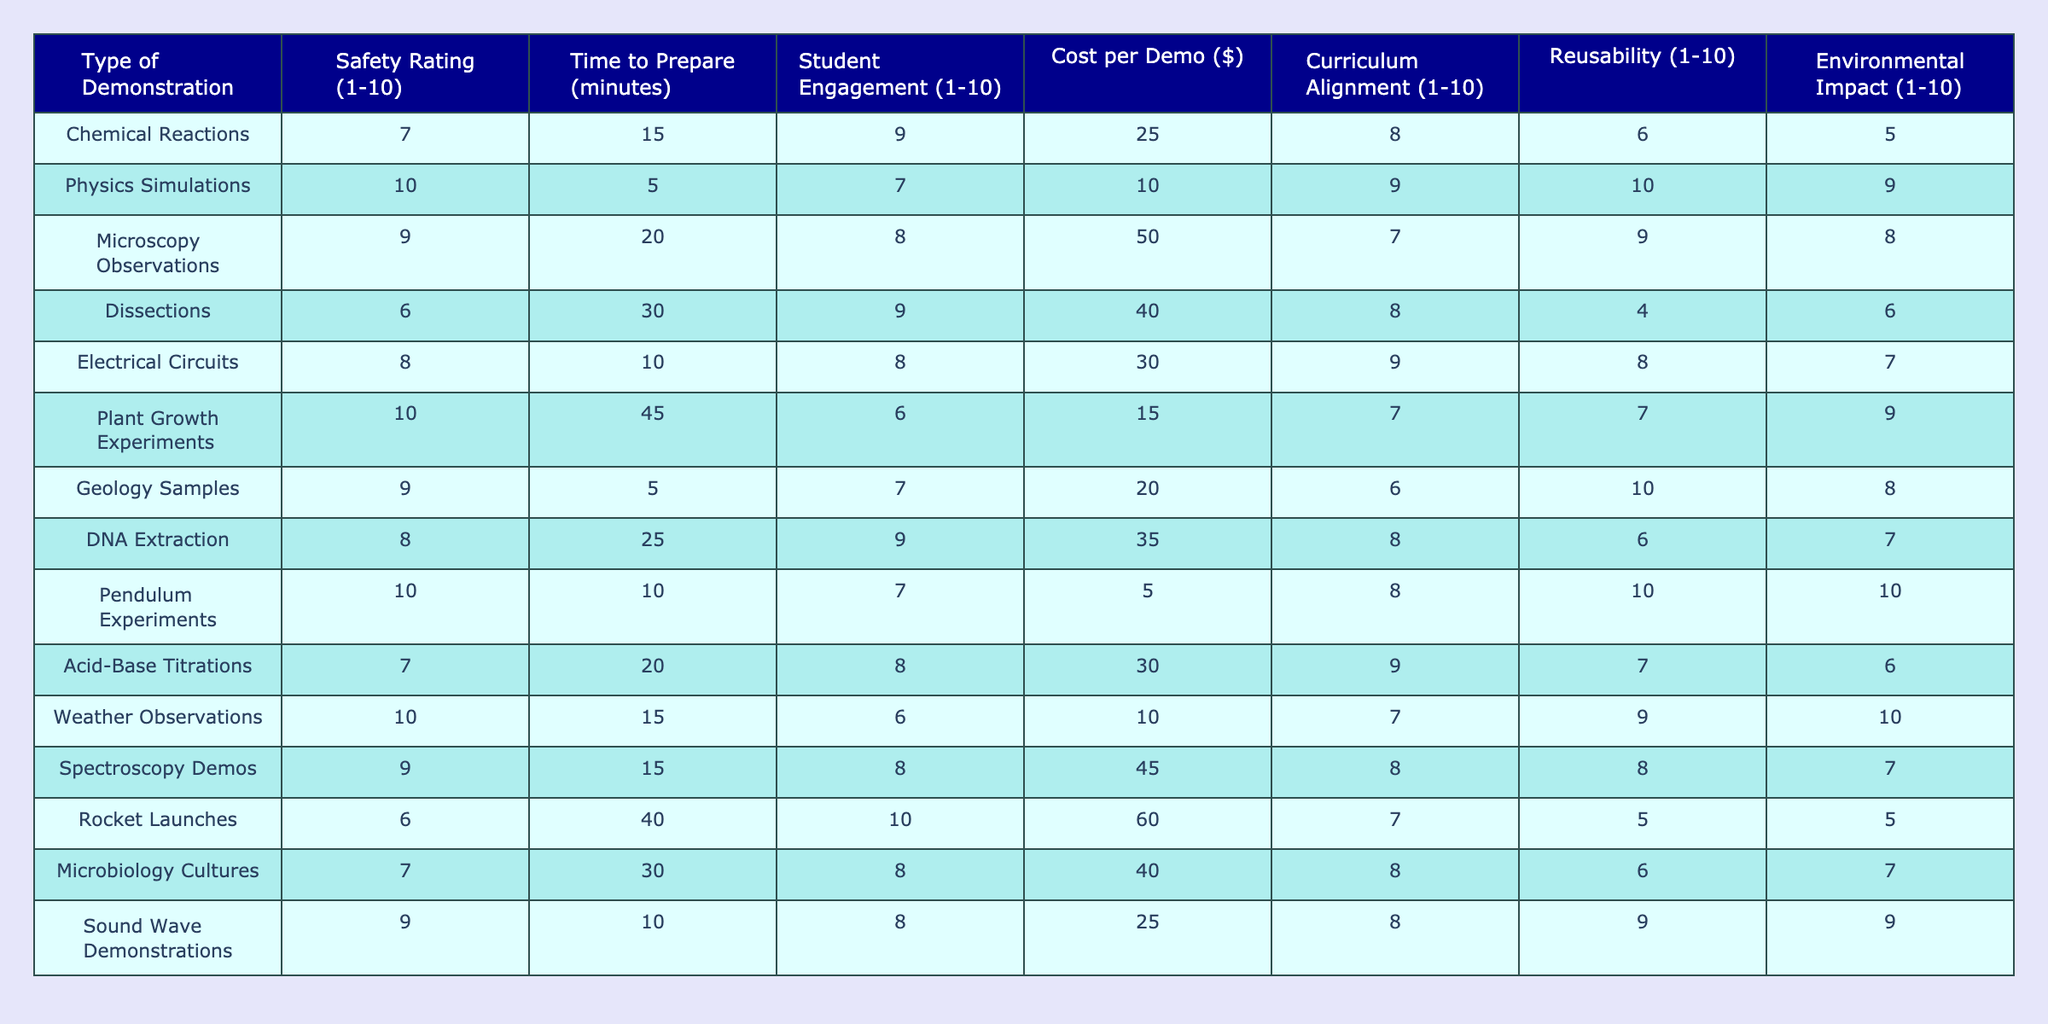What is the safety rating for Physics Simulations? The safety rating is directly listed under the "Safety Rating" column for Physics Simulations, which is 10.
Answer: 10 What is the time to prepare for Dissections? The preparation time for Dissections can be found in the "Time to Prepare" column, which indicates 30 minutes.
Answer: 30 minutes Which type of demonstration has the highest cost per demo? By comparing the values in the "Cost per Demo" column, Rocket Launches has the highest cost at $60.
Answer: $60 What is the average student engagement rating for all demonstrations? The student engagement ratings are summed (9+7+8+9+8+6+7+9+8+10+8+7+8+10= 102), then divided by the number of demonstrations (14), giving an average of 102/14 ≈ 7.29.
Answer: Approximately 7.29 Is the curriculum alignment rating for Geology Samples greater than 6? The table shows a curriculum alignment rating of 6 for Geology Samples, which is not greater than 6.
Answer: No Which type of demonstration has the best reusability rating? By looking at the "Reusability" column, Physics Simulations has the highest rating of 10.
Answer: Physics Simulations How many types of demonstrations have a safety rating of 10? The safety ratings can be counted: Physics Simulations, Pendulum Experiments, and Weather Observations each have a rating of 10, giving us a total of 3 demonstrations.
Answer: 3 What is the cost difference between Acid-Base Titrations and Microscopy Observations? The cost for Acid-Base Titrations is $30 and for Microscopy Observations, it is $50. Thus, the difference is calculated as 50 - 30 = 20.
Answer: $20 Which demonstration had the lowest student engagement rating? The "Student Engagement" column shows Plant Growth Experiments has the lowest rating of 6 among the listed demonstrations.
Answer: Plant Growth Experiments Is there an environmental impact rating of 10? Checking the "Environmental Impact" column reveals that Pendulum Experiments and Weather Observations both have a rating of 10, confirming the existence of such ratings.
Answer: Yes What types of demonstrations have a preparation time of 20 minutes or less, and what is their average student engagement rating? Looking at the "Time to Prepare" column, the demonstrations with preparation times of 20 minutes or less are Physics Simulations (5), Electrical Circuits (10), Pendulum Experiments (10), and Sound Wave Demonstrations (10). Their student engagement ratings (7, 8, 10, and 8) sum to 33, and the average is 33 / 4 = 8.25.
Answer: Approximately 8.25 